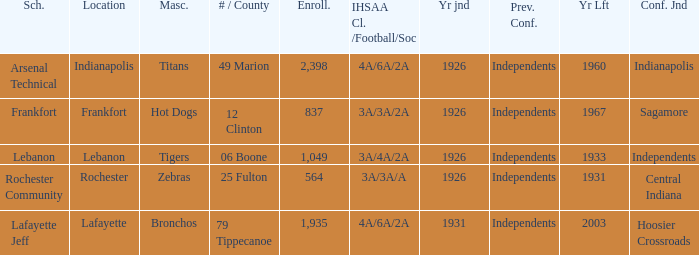What is the highest enrollment for rochester community school? 564.0. 